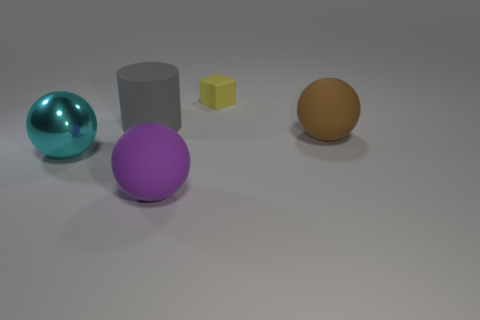There is a thing behind the cylinder; is it the same shape as the big brown thing?
Offer a terse response. No. Are there fewer tiny blue rubber things than gray things?
Ensure brevity in your answer.  Yes. Is there anything else of the same color as the cube?
Make the answer very short. No. What is the shape of the matte thing in front of the brown thing?
Make the answer very short. Sphere. Does the small matte object have the same color as the big rubber thing that is behind the large brown ball?
Your answer should be very brief. No. Are there an equal number of cyan balls on the right side of the purple matte sphere and big cyan metallic things in front of the brown matte sphere?
Your response must be concise. No. How many other objects are there of the same size as the rubber cylinder?
Provide a succinct answer. 3. What is the size of the yellow thing?
Your answer should be very brief. Small. Is the big purple thing made of the same material as the sphere that is on the right side of the small yellow rubber block?
Offer a very short reply. Yes. Is there another thing that has the same shape as the yellow rubber object?
Keep it short and to the point. No. 